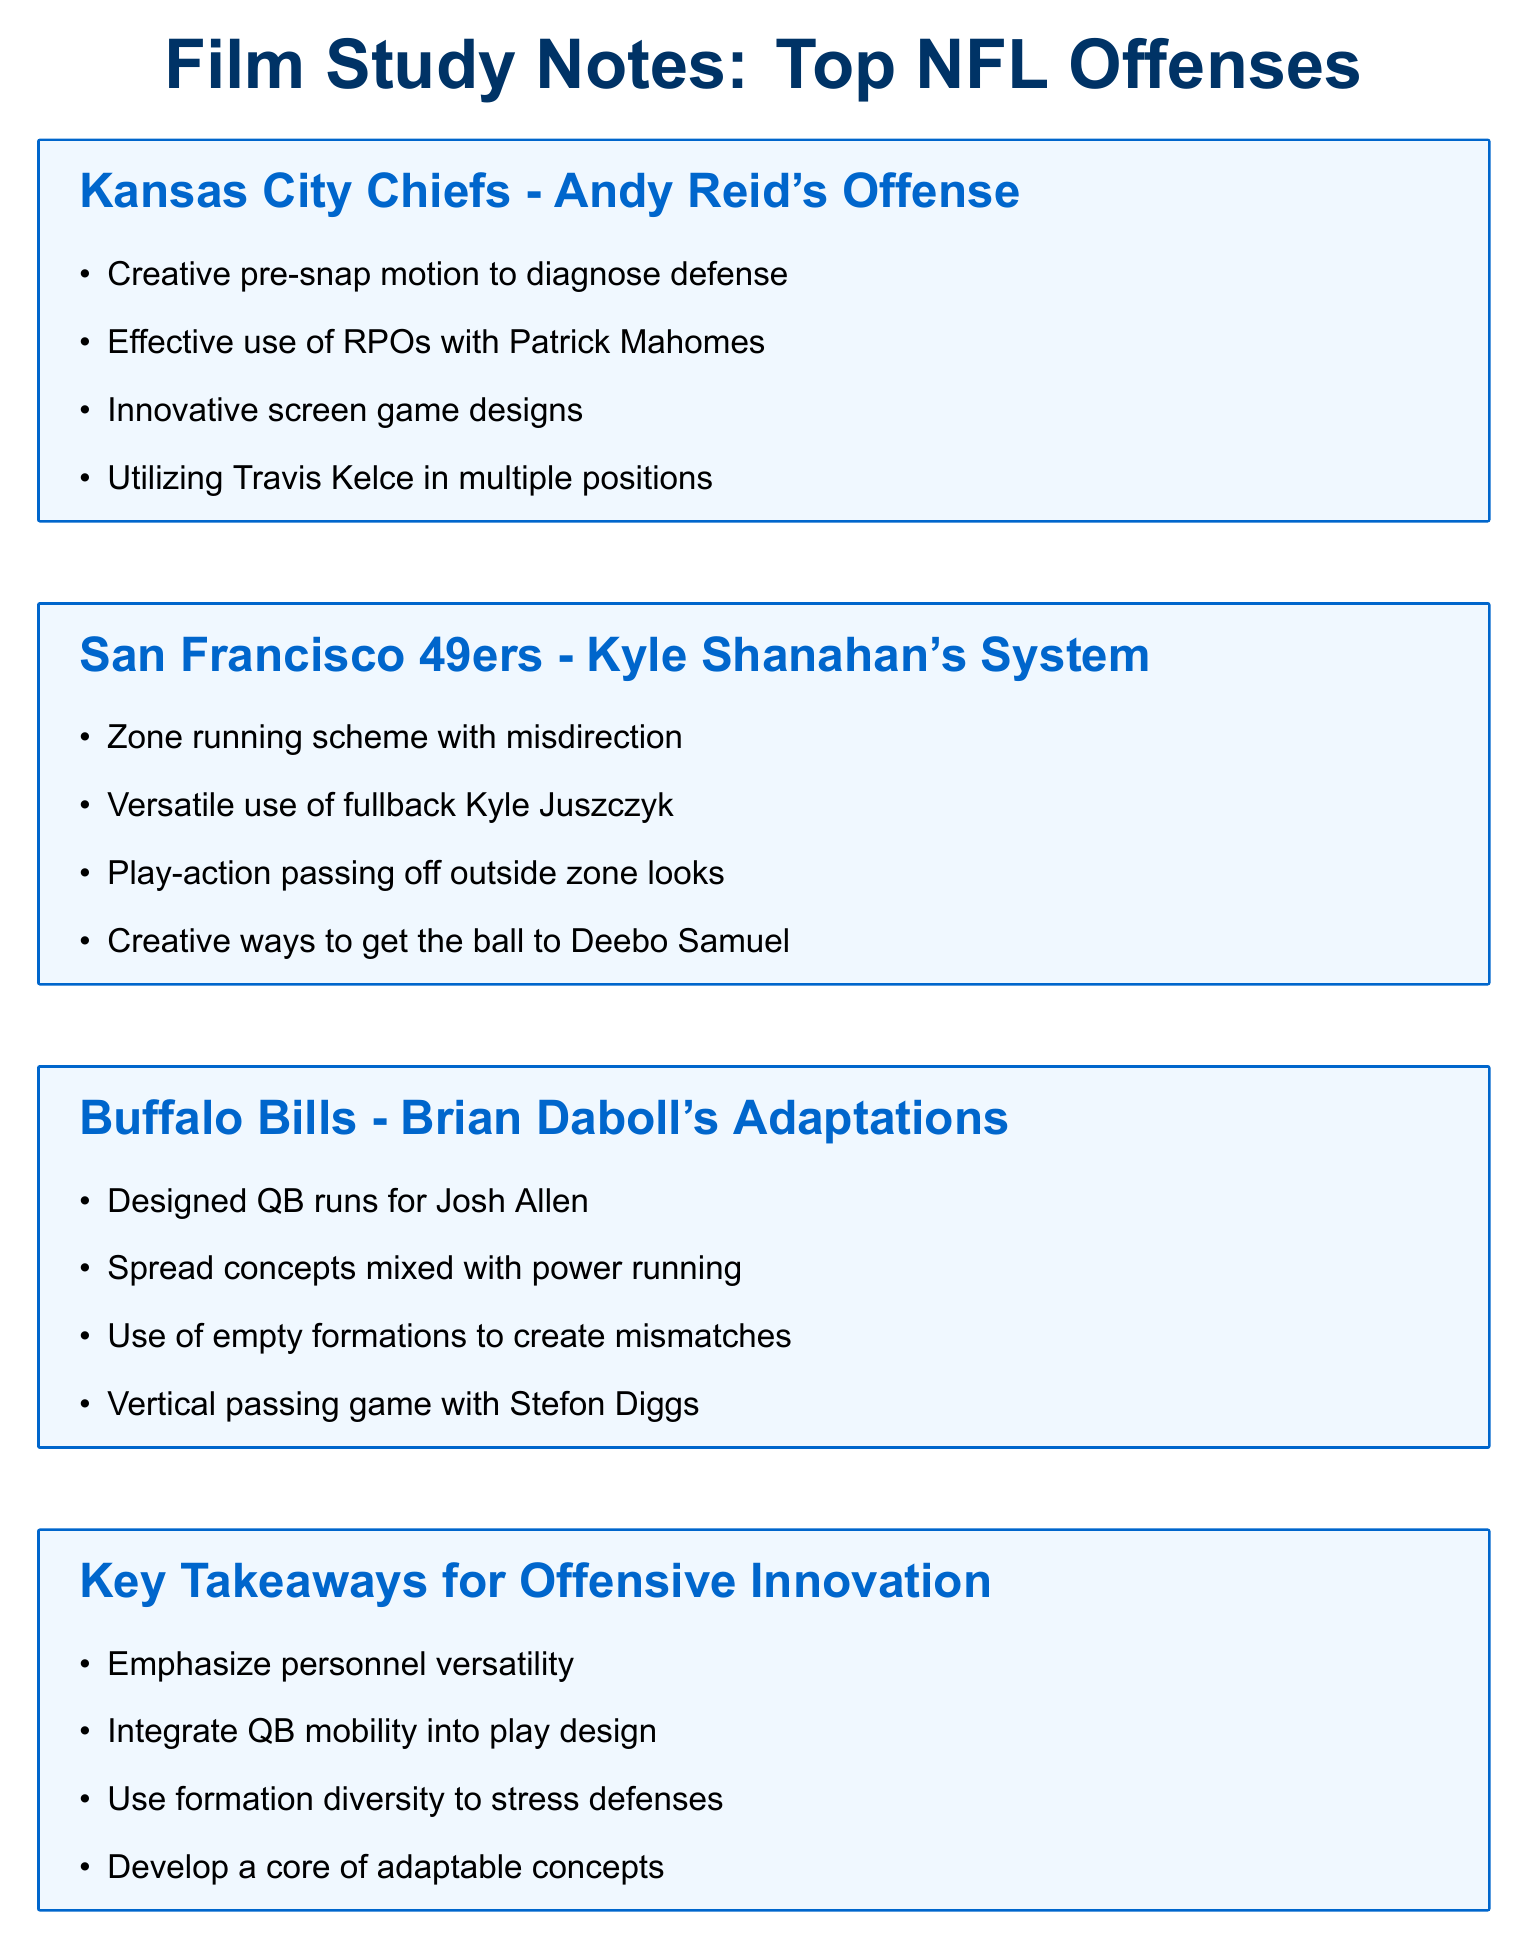What is the title of the document? The title is provided at the beginning of the document, summarizing its content.
Answer: Film Study Notes: Top NFL Offenses Who is the head coach of the Kansas City Chiefs? The document mentions Andy Reid as the head coach associated with the offensive style of the Chiefs.
Answer: Andy Reid What unique role does Kyle Juszczyk have in the 49ers' offense? The document highlights his versatile use in the system, which emphasizes multiple functions.
Answer: Versatile use of fullback Which quarterback's runs are designed as part of the Buffalo Bills' offense? The specific player mentioned for designed runs is identified in the Buffalo Bills section.
Answer: Josh Allen What offensive concept is emphasized across all teams in the key takeaways? The document lists key themes that are common among the top offenses, focusing on adaptability.
Answer: Personnel versatility What innovative strategy does the Kansas City Chiefs employ to diagnose defenses? The Chiefs' method for pre-snap adjustments is noted in their section of the document.
Answer: Creative pre-snap motion What type of running scheme does the San Francisco 49ers utilize? The document categorizes the offense's running approach, indicating a specific method employed.
Answer: Zone running scheme What is a core takeaway related to quarterback involvement mentioned in the document? The key takeaway regarding QB play design emphasizes the role of mobility.
Answer: Integrate QB mobility into play design 